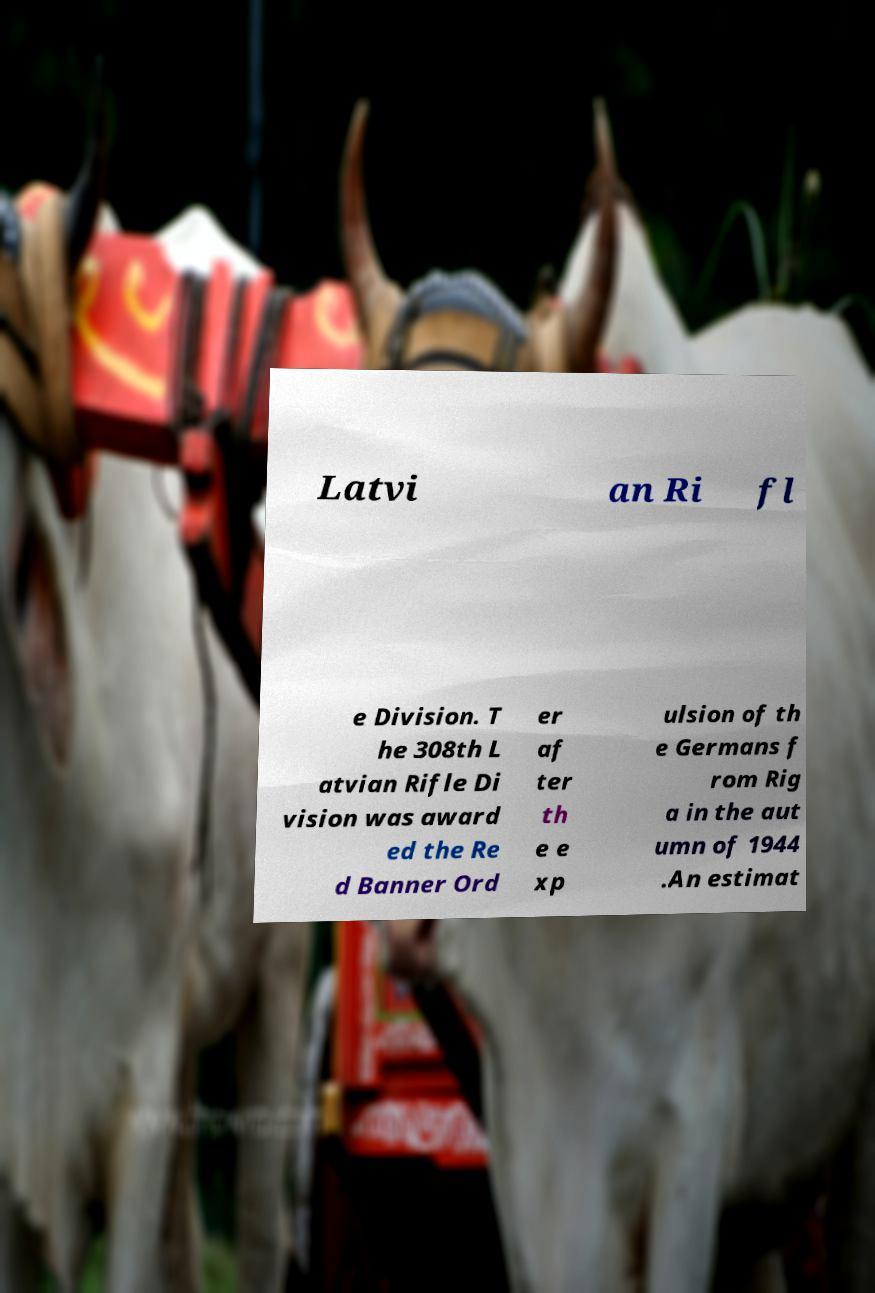Can you read and provide the text displayed in the image?This photo seems to have some interesting text. Can you extract and type it out for me? Latvi an Ri fl e Division. T he 308th L atvian Rifle Di vision was award ed the Re d Banner Ord er af ter th e e xp ulsion of th e Germans f rom Rig a in the aut umn of 1944 .An estimat 